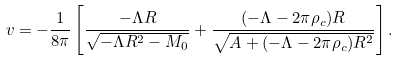Convert formula to latex. <formula><loc_0><loc_0><loc_500><loc_500>v = - \frac { 1 } { 8 \pi } \left [ \frac { - \Lambda R } { \sqrt { - \Lambda R ^ { 2 } - M _ { 0 } } } + \frac { ( - \Lambda - 2 \pi \rho _ { c } ) R } { \sqrt { A + ( - \Lambda - 2 \pi \rho _ { c } ) R ^ { 2 } } } \right ] .</formula> 